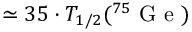<formula> <loc_0><loc_0><loc_500><loc_500>\simeq 3 5 \cdot T _ { 1 / 2 } ( ^ { 7 5 } G e )</formula> 